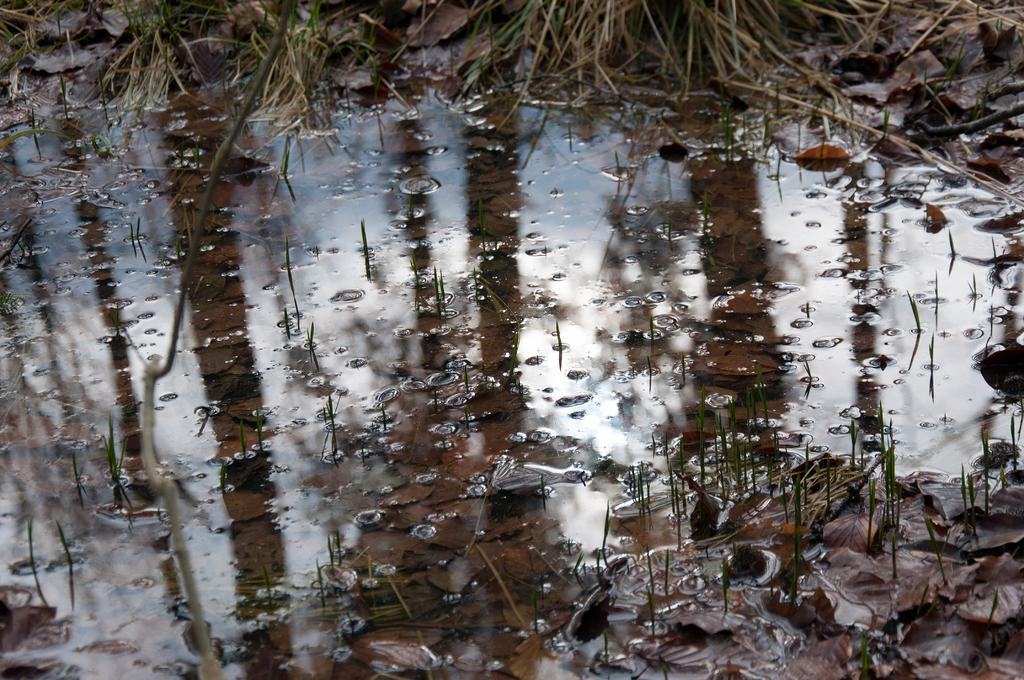What is the primary element in the image? There is water in the image. What can be found within the water? There are plants and leaves in the water. Are there any visible effects of the water movement? Yes, there are water bubbles in the image. How many tents can be seen in the image? There are no tents present in the image. What type of snails are swimming among the plants in the water? There are no snails visible in the image; only plants and leaves are present in the water. 